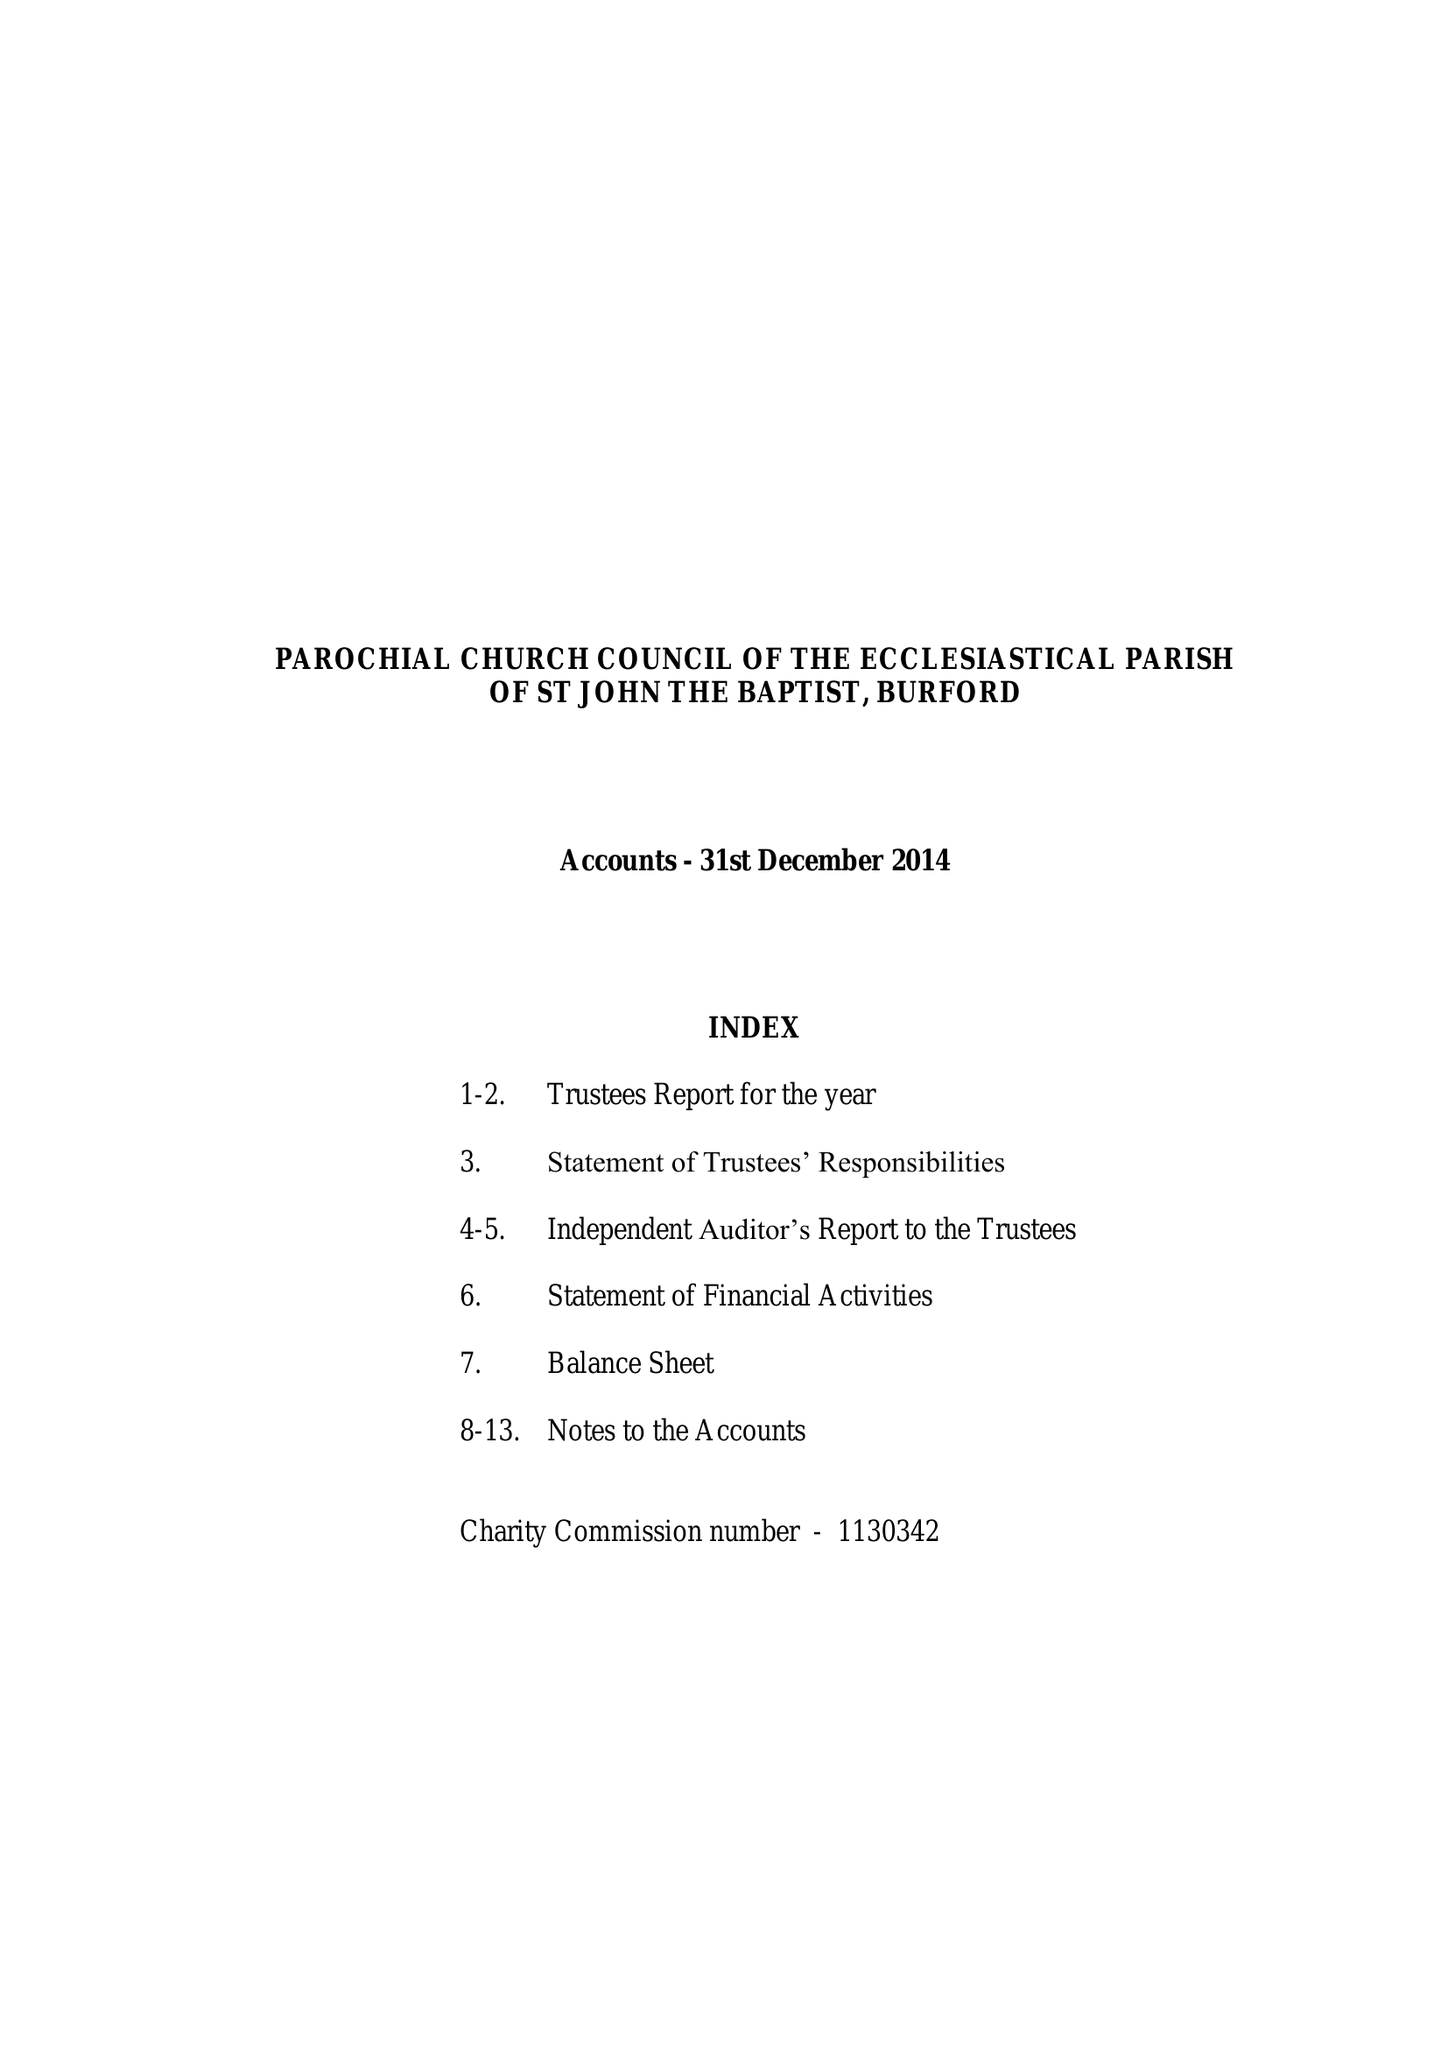What is the value for the spending_annually_in_british_pounds?
Answer the question using a single word or phrase. 306295.00 